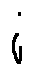Convert formula to latex. <formula><loc_0><loc_0><loc_500><loc_500>i</formula> 